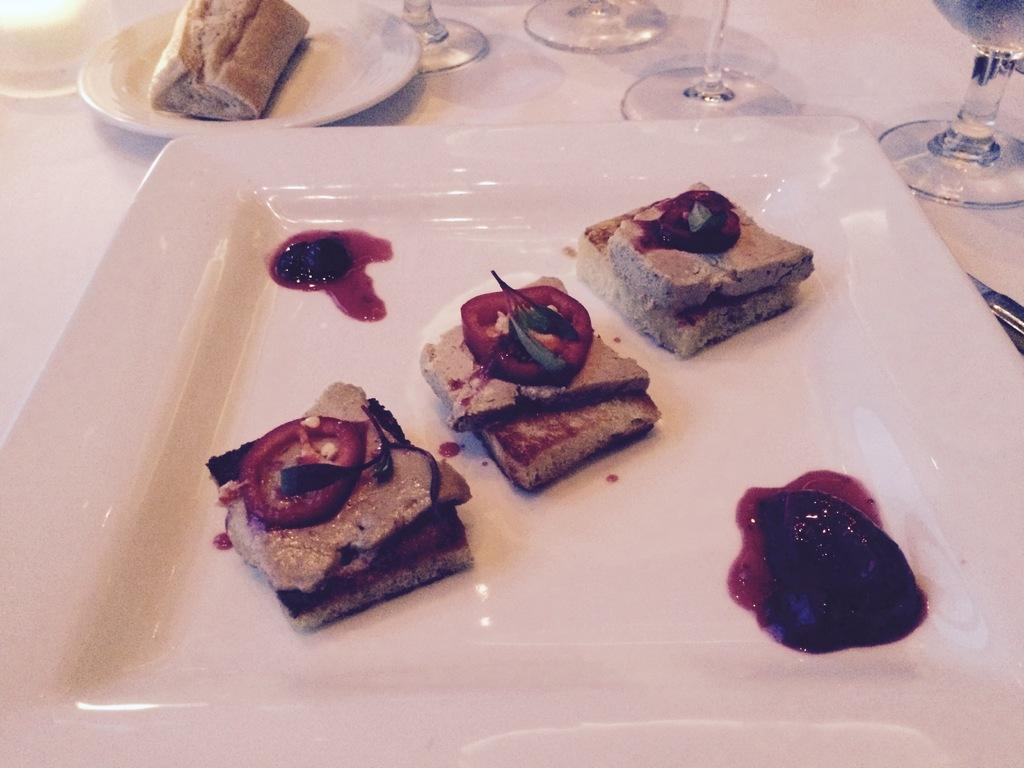What type of dish is used to hold the food items in the image? There are food items in a white plate in the image. What type of glassware is present in the image? There are wine glasses in the image. Can you describe the arrangement of the plates in the image? There is a plate at the back in the image. How many fingers can be seen touching the food items in the image? There are no fingers touching the food items in the image. What type of bit is being taken out of the food in the image? There is no bit being taken out of the food in the image. 